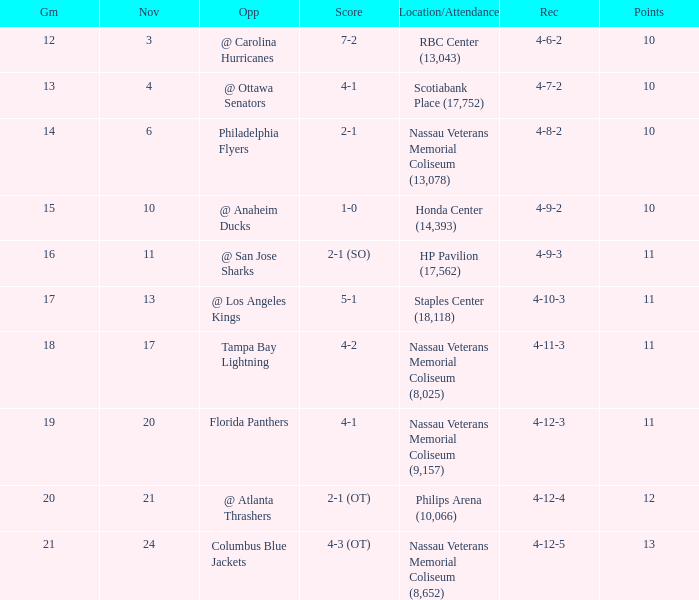What is the least amount of points? 10.0. 